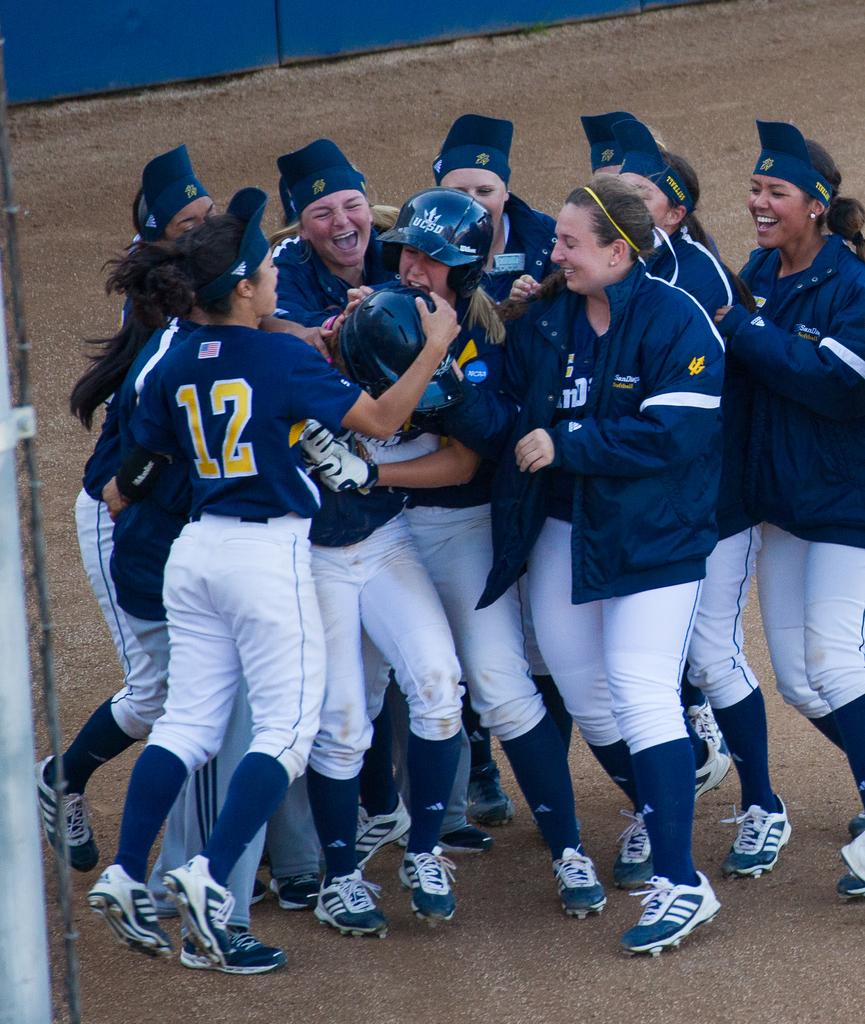<image>
Provide a brief description of the given image. The player on the far left is wearing the number 12 